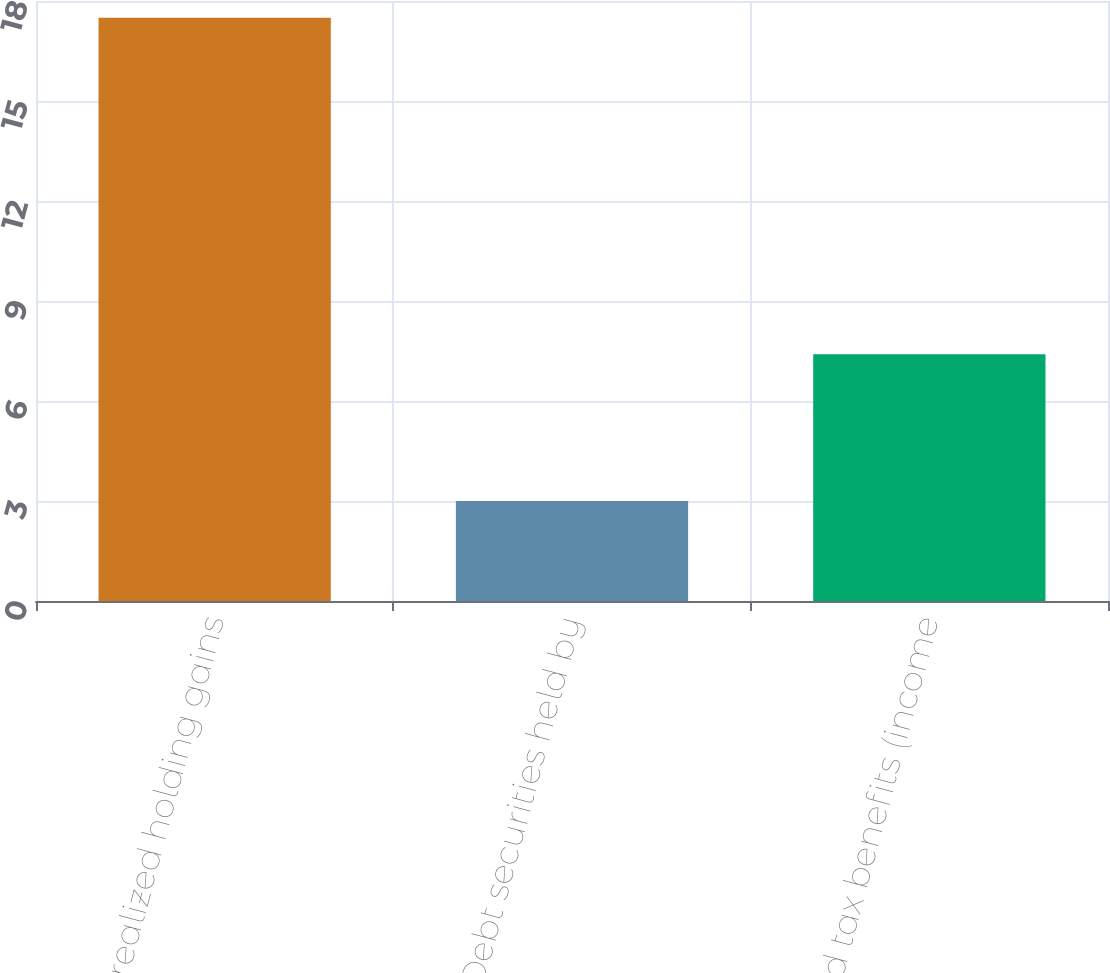Convert chart to OTSL. <chart><loc_0><loc_0><loc_500><loc_500><bar_chart><fcel>Net unrealized holding gains<fcel>Debt securities held by<fcel>Deferred tax benefits (income<nl><fcel>17.5<fcel>3<fcel>7.4<nl></chart> 